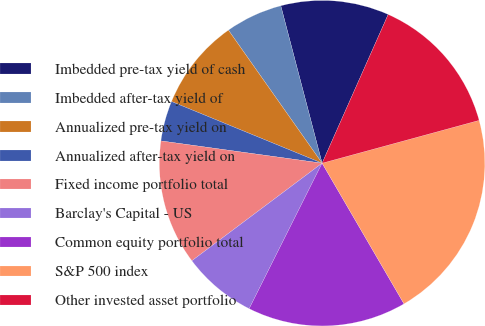<chart> <loc_0><loc_0><loc_500><loc_500><pie_chart><fcel>Imbedded pre-tax yield of cash<fcel>Imbedded after-tax yield of<fcel>Annualized pre-tax yield on<fcel>Annualized after-tax yield on<fcel>Fixed income portfolio total<fcel>Barclay's Capital - US<fcel>Common equity portfolio total<fcel>S&P 500 index<fcel>Other invested asset portfolio<nl><fcel>10.74%<fcel>5.68%<fcel>9.05%<fcel>4.0%<fcel>12.42%<fcel>7.37%<fcel>15.79%<fcel>20.85%<fcel>14.11%<nl></chart> 